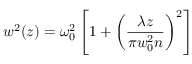Convert formula to latex. <formula><loc_0><loc_0><loc_500><loc_500>w ^ { 2 } ( z ) = \omega _ { 0 } ^ { 2 } \left [ 1 + \left ( \frac { \lambda z } { \pi w _ { 0 } ^ { 2 } n } \right ) ^ { 2 } \right ]</formula> 